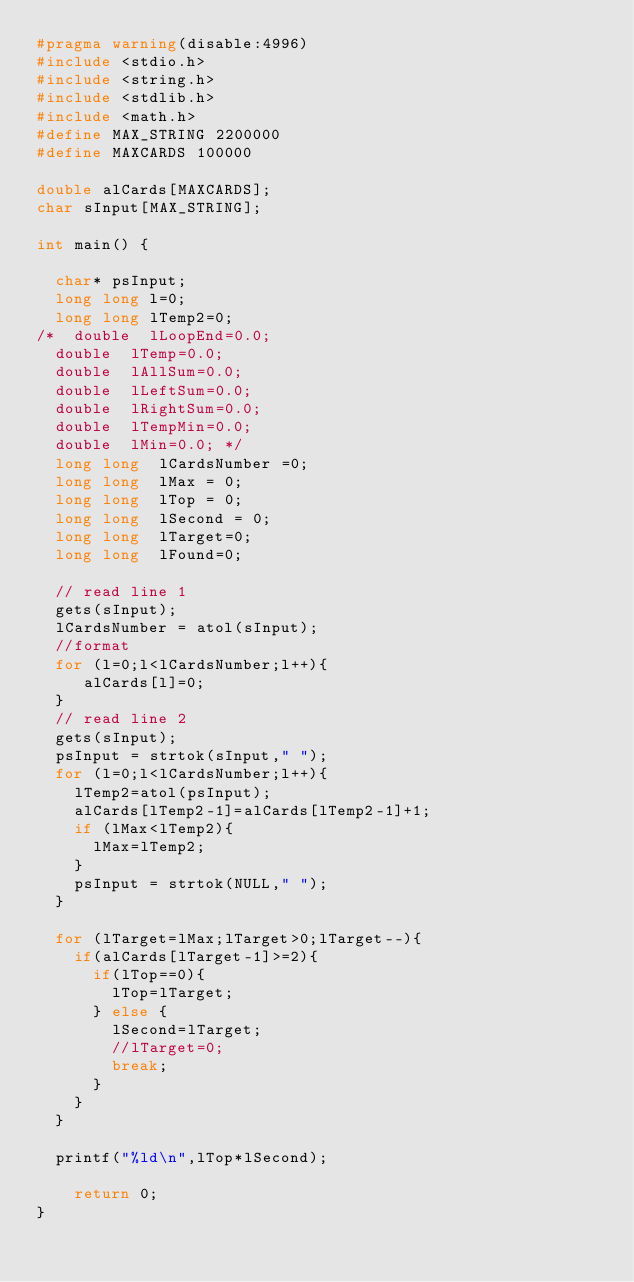<code> <loc_0><loc_0><loc_500><loc_500><_C_>#pragma warning(disable:4996)
#include <stdio.h>
#include <string.h>
#include <stdlib.h>
#include <math.h>
#define MAX_STRING 2200000 
#define MAXCARDS 100000

double alCards[MAXCARDS];
char sInput[MAX_STRING];

int main() {

	char* psInput;
	long long l=0;
	long long lTemp2=0;
/*	double  lLoopEnd=0.0;
	double  lTemp=0.0;
	double  lAllSum=0.0;
	double  lLeftSum=0.0;
	double  lRightSum=0.0;
	double  lTempMin=0.0;
	double  lMin=0.0; */
	long long  lCardsNumber =0;
	long long  lMax = 0;
	long long  lTop = 0;
	long long  lSecond = 0;
	long long  lTarget=0;
	long long  lFound=0;

	// read line 1
	gets(sInput);
	lCardsNumber = atol(sInput);
	//format
	for (l=0;l<lCardsNumber;l++){
		 alCards[l]=0;
	}
	// read line 2
	gets(sInput);
	psInput = strtok(sInput," ");
	for (l=0;l<lCardsNumber;l++){
		lTemp2=atol(psInput);
		alCards[lTemp2-1]=alCards[lTemp2-1]+1;
		if (lMax<lTemp2){
			lMax=lTemp2;
		}
		psInput = strtok(NULL," ");
	}

	for (lTarget=lMax;lTarget>0;lTarget--){
		if(alCards[lTarget-1]>=2){
			if(lTop==0){
				lTop=lTarget;
			} else {
				lSecond=lTarget;
				//lTarget=0;
				break;
			}
		}
	}

	printf("%ld\n",lTop*lSecond);

    return 0;
}
</code> 